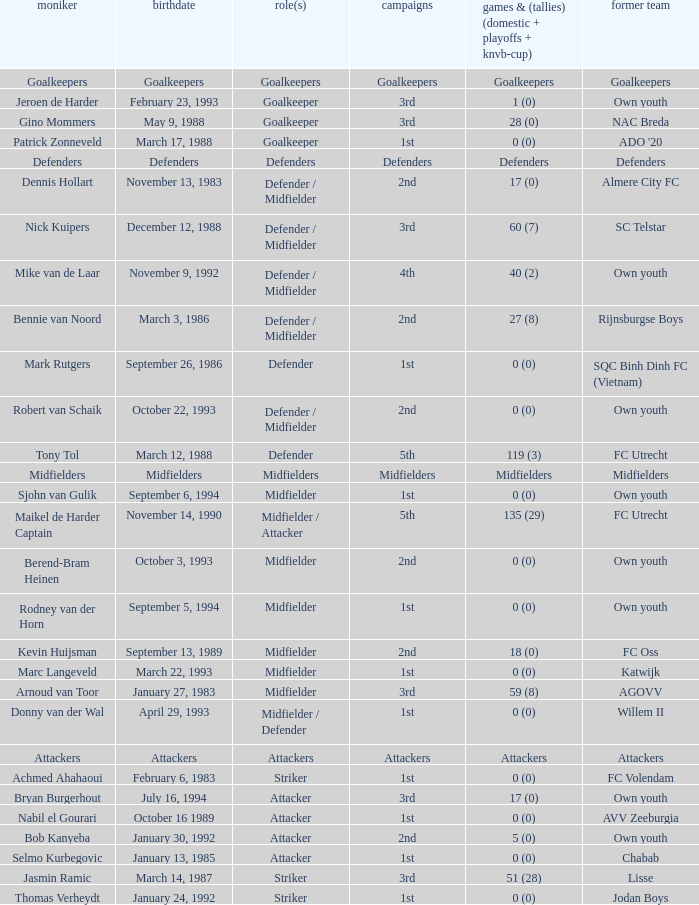What previous club was born on October 22, 1993? Own youth. 